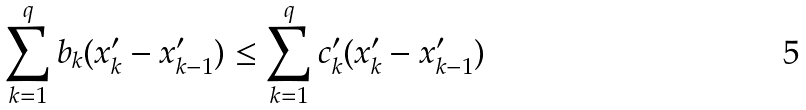<formula> <loc_0><loc_0><loc_500><loc_500>\sum ^ { q } _ { k = 1 } b _ { k } ( x ^ { \prime } _ { k } - x ^ { \prime } _ { k - 1 } ) \leq \sum ^ { q } _ { k = 1 } c ^ { \prime } _ { k } ( x ^ { \prime } _ { k } - x ^ { \prime } _ { k - 1 } )</formula> 